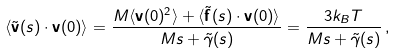Convert formula to latex. <formula><loc_0><loc_0><loc_500><loc_500>\langle { \tilde { \mathbf v } } ( s ) \cdot { \mathbf v } ( 0 ) \rangle = \frac { M \langle { \mathbf v } ( 0 ) ^ { 2 } \rangle + \langle { \tilde { \mathbf f } } ( s ) \cdot { \mathbf v } ( 0 ) \rangle } { M s + { \tilde { \gamma } } ( s ) } = \frac { 3 k _ { B } T } { M s + { \tilde { \gamma } } ( s ) } \, ,</formula> 